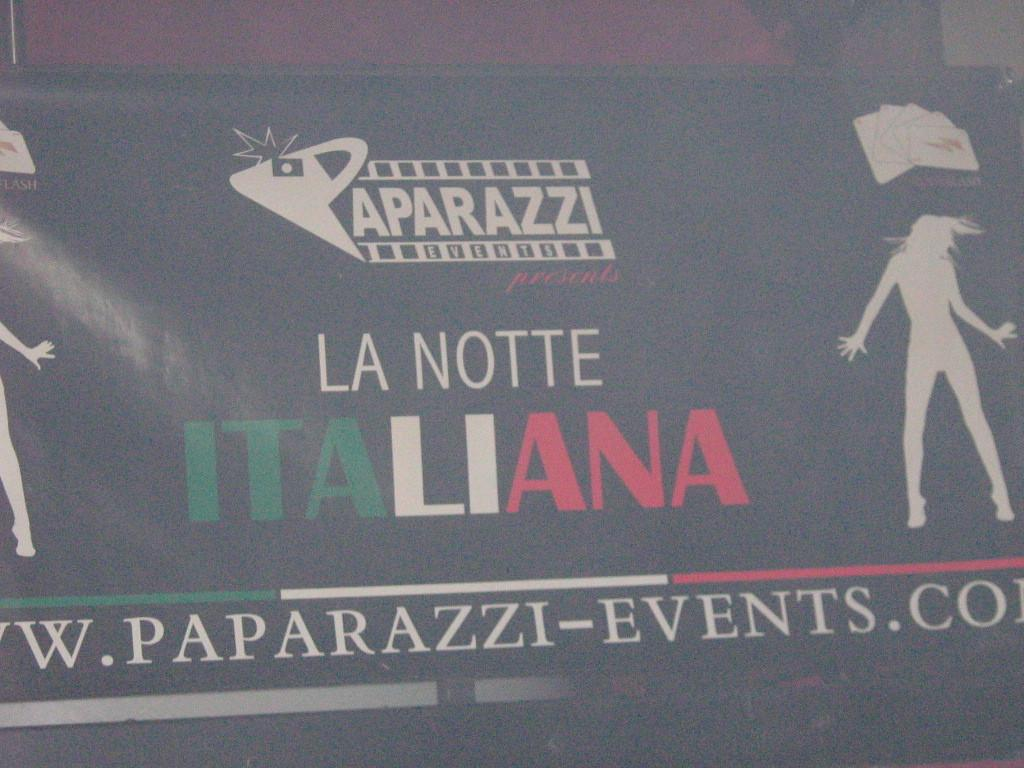What is the main object in the image? There is a board in the image. What can be found on the board? The board has pictures and text on it. Where is the girl standing next to the pie on the boat in the image? There is no girl, pie, or boat present in the image; it only features a board with pictures and text. 